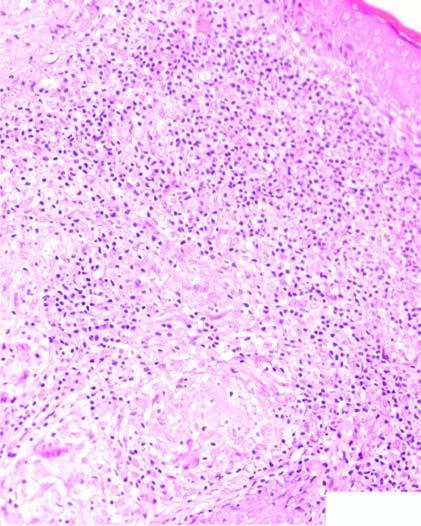does one marrow trephine biopsy in aplastic anaemia contain caseating epithelioid cell granulomas having giant cells and lymphocytes?
Answer the question using a single word or phrase. No 